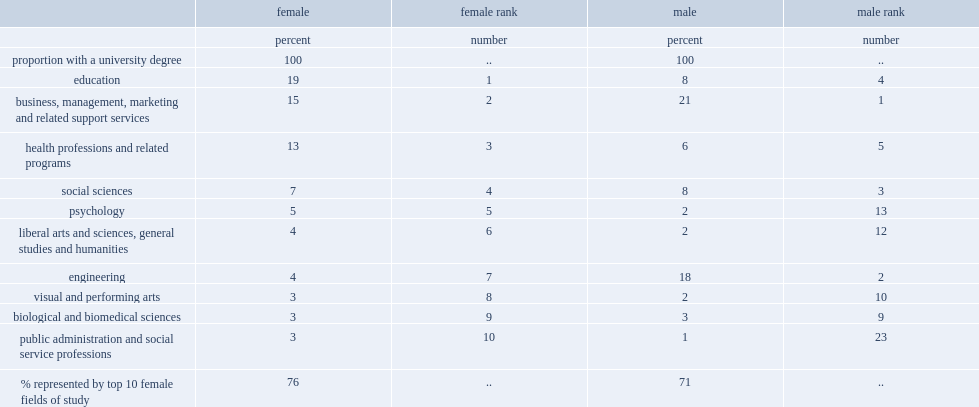What was the proportion of women aged 25 to 64 with a university degree in education in 2011? 19.0. What was the proportion of women aged 25 to 64 with a university degree in health professions and related programs in 2011? 13.0. In 2011, women were more likely to have a university degree in health professions and related programs or education? Education. What was the proportion of women that had university degrees in education, health professions and related programs, business, management, marketing and related support services in 2011? 47. What was the proportion of men aged 25 to 64 that had a university degree in education in 2011? 8.0. What was the proportion of men aged 25 to 64 that had a university degree in business, management, marketing and related support services? 21.0. What was the proportion of men aged 25 to 64 that had a university degree in health professions and related programs? 6.0. What was the ranking of engineering among female university degree holders in 2011? 7.0. What was the ranking of engineering among male university degree holders in 2011? 2.0. 